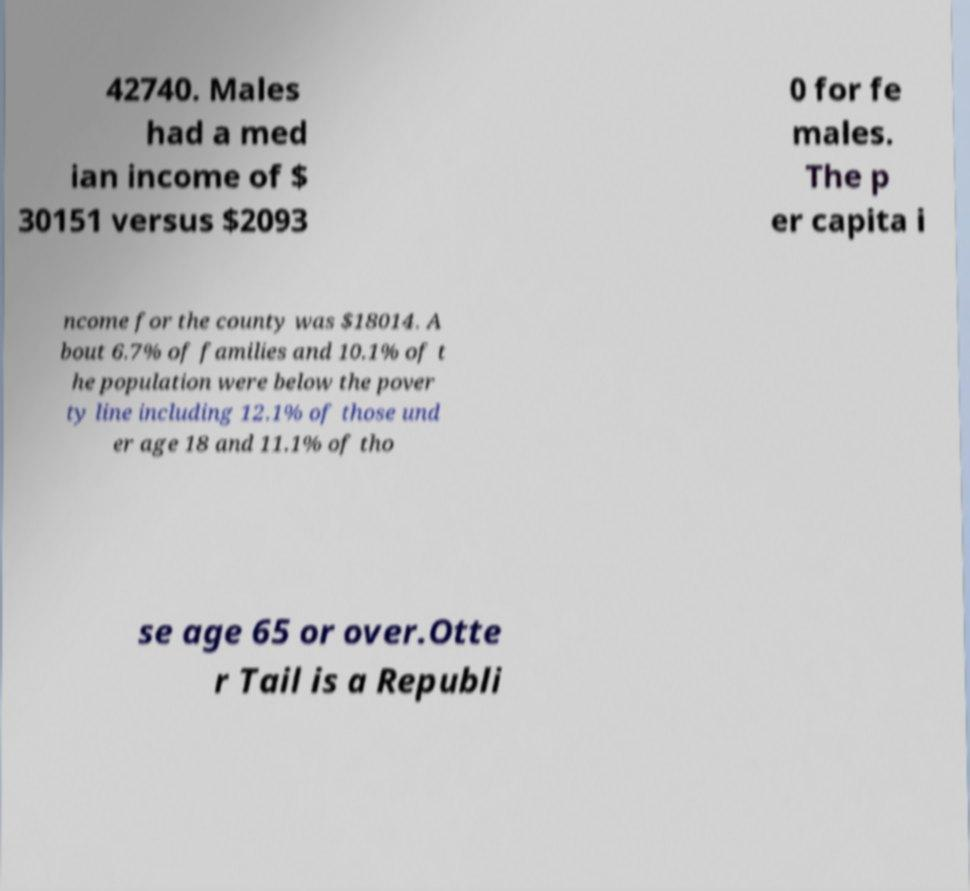Could you extract and type out the text from this image? 42740. Males had a med ian income of $ 30151 versus $2093 0 for fe males. The p er capita i ncome for the county was $18014. A bout 6.7% of families and 10.1% of t he population were below the pover ty line including 12.1% of those und er age 18 and 11.1% of tho se age 65 or over.Otte r Tail is a Republi 